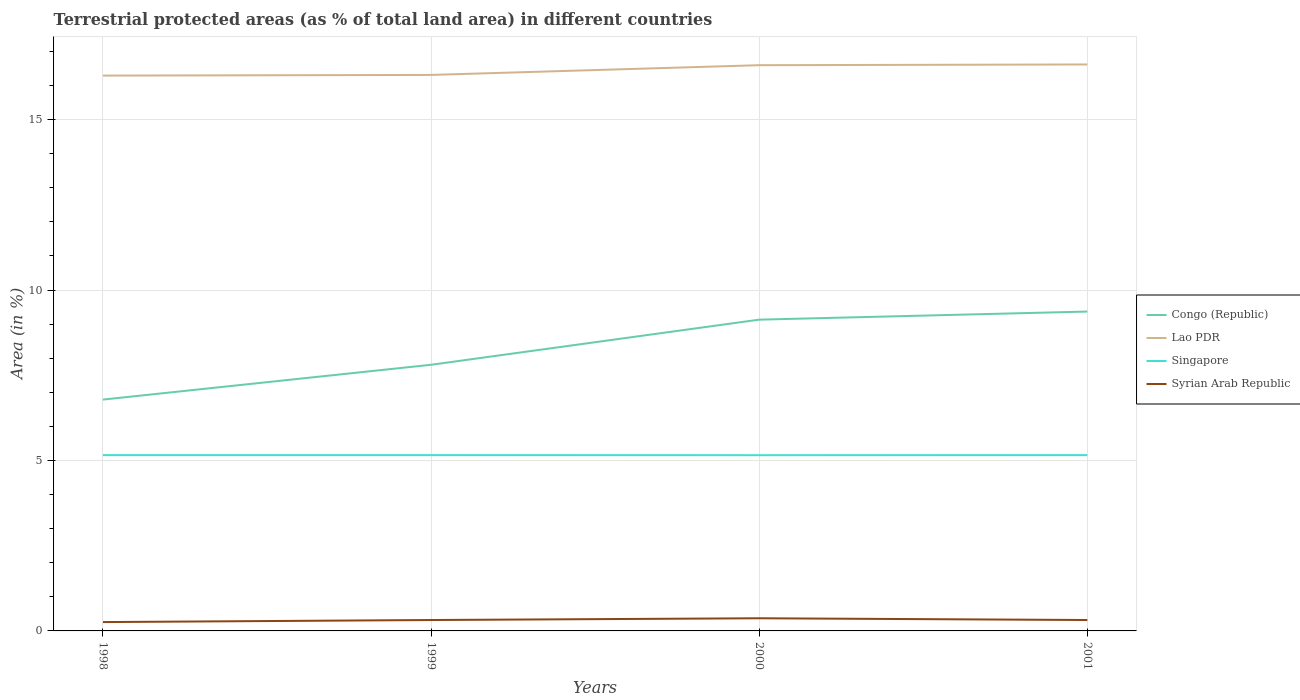Is the number of lines equal to the number of legend labels?
Provide a succinct answer. Yes. Across all years, what is the maximum percentage of terrestrial protected land in Congo (Republic)?
Give a very brief answer. 6.79. In which year was the percentage of terrestrial protected land in Singapore maximum?
Offer a very short reply. 2000. What is the total percentage of terrestrial protected land in Syrian Arab Republic in the graph?
Your answer should be compact. -0.06. What is the difference between the highest and the second highest percentage of terrestrial protected land in Congo (Republic)?
Offer a terse response. 2.58. How many lines are there?
Make the answer very short. 4. How many years are there in the graph?
Give a very brief answer. 4. Are the values on the major ticks of Y-axis written in scientific E-notation?
Keep it short and to the point. No. Does the graph contain any zero values?
Your response must be concise. No. How are the legend labels stacked?
Keep it short and to the point. Vertical. What is the title of the graph?
Keep it short and to the point. Terrestrial protected areas (as % of total land area) in different countries. Does "Australia" appear as one of the legend labels in the graph?
Offer a terse response. No. What is the label or title of the Y-axis?
Your answer should be compact. Area (in %). What is the Area (in %) of Congo (Republic) in 1998?
Your response must be concise. 6.79. What is the Area (in %) of Lao PDR in 1998?
Offer a terse response. 16.29. What is the Area (in %) of Singapore in 1998?
Keep it short and to the point. 5.16. What is the Area (in %) of Syrian Arab Republic in 1998?
Provide a short and direct response. 0.26. What is the Area (in %) in Congo (Republic) in 1999?
Your answer should be compact. 7.81. What is the Area (in %) in Lao PDR in 1999?
Keep it short and to the point. 16.31. What is the Area (in %) of Singapore in 1999?
Your response must be concise. 5.16. What is the Area (in %) of Syrian Arab Republic in 1999?
Make the answer very short. 0.32. What is the Area (in %) of Congo (Republic) in 2000?
Your response must be concise. 9.13. What is the Area (in %) of Lao PDR in 2000?
Offer a very short reply. 16.6. What is the Area (in %) in Singapore in 2000?
Make the answer very short. 5.16. What is the Area (in %) of Syrian Arab Republic in 2000?
Ensure brevity in your answer.  0.37. What is the Area (in %) in Congo (Republic) in 2001?
Your response must be concise. 9.37. What is the Area (in %) in Lao PDR in 2001?
Ensure brevity in your answer.  16.62. What is the Area (in %) of Singapore in 2001?
Ensure brevity in your answer.  5.16. What is the Area (in %) in Syrian Arab Republic in 2001?
Offer a terse response. 0.32. Across all years, what is the maximum Area (in %) in Congo (Republic)?
Offer a terse response. 9.37. Across all years, what is the maximum Area (in %) in Lao PDR?
Your response must be concise. 16.62. Across all years, what is the maximum Area (in %) of Singapore?
Provide a succinct answer. 5.16. Across all years, what is the maximum Area (in %) in Syrian Arab Republic?
Ensure brevity in your answer.  0.37. Across all years, what is the minimum Area (in %) in Congo (Republic)?
Your response must be concise. 6.79. Across all years, what is the minimum Area (in %) in Lao PDR?
Give a very brief answer. 16.29. Across all years, what is the minimum Area (in %) of Singapore?
Offer a terse response. 5.16. Across all years, what is the minimum Area (in %) of Syrian Arab Republic?
Provide a short and direct response. 0.26. What is the total Area (in %) in Congo (Republic) in the graph?
Ensure brevity in your answer.  33.1. What is the total Area (in %) in Lao PDR in the graph?
Provide a short and direct response. 65.82. What is the total Area (in %) in Singapore in the graph?
Ensure brevity in your answer.  20.63. What is the total Area (in %) in Syrian Arab Republic in the graph?
Make the answer very short. 1.27. What is the difference between the Area (in %) of Congo (Republic) in 1998 and that in 1999?
Make the answer very short. -1.02. What is the difference between the Area (in %) in Lao PDR in 1998 and that in 1999?
Your answer should be very brief. -0.02. What is the difference between the Area (in %) in Syrian Arab Republic in 1998 and that in 1999?
Your answer should be compact. -0.06. What is the difference between the Area (in %) in Congo (Republic) in 1998 and that in 2000?
Your response must be concise. -2.35. What is the difference between the Area (in %) in Lao PDR in 1998 and that in 2000?
Your answer should be very brief. -0.31. What is the difference between the Area (in %) in Singapore in 1998 and that in 2000?
Provide a short and direct response. 0. What is the difference between the Area (in %) of Syrian Arab Republic in 1998 and that in 2000?
Offer a very short reply. -0.11. What is the difference between the Area (in %) in Congo (Republic) in 1998 and that in 2001?
Your answer should be compact. -2.58. What is the difference between the Area (in %) of Lao PDR in 1998 and that in 2001?
Your response must be concise. -0.33. What is the difference between the Area (in %) in Syrian Arab Republic in 1998 and that in 2001?
Provide a succinct answer. -0.06. What is the difference between the Area (in %) in Congo (Republic) in 1999 and that in 2000?
Make the answer very short. -1.32. What is the difference between the Area (in %) in Lao PDR in 1999 and that in 2000?
Your answer should be very brief. -0.29. What is the difference between the Area (in %) of Singapore in 1999 and that in 2000?
Provide a short and direct response. 0. What is the difference between the Area (in %) of Syrian Arab Republic in 1999 and that in 2000?
Your answer should be very brief. -0.05. What is the difference between the Area (in %) in Congo (Republic) in 1999 and that in 2001?
Provide a short and direct response. -1.56. What is the difference between the Area (in %) in Lao PDR in 1999 and that in 2001?
Provide a short and direct response. -0.31. What is the difference between the Area (in %) in Syrian Arab Republic in 1999 and that in 2001?
Your answer should be compact. 0. What is the difference between the Area (in %) in Congo (Republic) in 2000 and that in 2001?
Give a very brief answer. -0.24. What is the difference between the Area (in %) of Lao PDR in 2000 and that in 2001?
Ensure brevity in your answer.  -0.02. What is the difference between the Area (in %) in Singapore in 2000 and that in 2001?
Make the answer very short. -0. What is the difference between the Area (in %) of Syrian Arab Republic in 2000 and that in 2001?
Offer a terse response. 0.05. What is the difference between the Area (in %) in Congo (Republic) in 1998 and the Area (in %) in Lao PDR in 1999?
Offer a very short reply. -9.52. What is the difference between the Area (in %) in Congo (Republic) in 1998 and the Area (in %) in Singapore in 1999?
Offer a terse response. 1.63. What is the difference between the Area (in %) in Congo (Republic) in 1998 and the Area (in %) in Syrian Arab Republic in 1999?
Provide a succinct answer. 6.47. What is the difference between the Area (in %) of Lao PDR in 1998 and the Area (in %) of Singapore in 1999?
Your response must be concise. 11.13. What is the difference between the Area (in %) of Lao PDR in 1998 and the Area (in %) of Syrian Arab Republic in 1999?
Offer a very short reply. 15.97. What is the difference between the Area (in %) of Singapore in 1998 and the Area (in %) of Syrian Arab Republic in 1999?
Offer a terse response. 4.84. What is the difference between the Area (in %) in Congo (Republic) in 1998 and the Area (in %) in Lao PDR in 2000?
Give a very brief answer. -9.81. What is the difference between the Area (in %) of Congo (Republic) in 1998 and the Area (in %) of Singapore in 2000?
Keep it short and to the point. 1.63. What is the difference between the Area (in %) in Congo (Republic) in 1998 and the Area (in %) in Syrian Arab Republic in 2000?
Offer a very short reply. 6.42. What is the difference between the Area (in %) of Lao PDR in 1998 and the Area (in %) of Singapore in 2000?
Offer a very short reply. 11.14. What is the difference between the Area (in %) of Lao PDR in 1998 and the Area (in %) of Syrian Arab Republic in 2000?
Provide a succinct answer. 15.92. What is the difference between the Area (in %) in Singapore in 1998 and the Area (in %) in Syrian Arab Republic in 2000?
Give a very brief answer. 4.79. What is the difference between the Area (in %) of Congo (Republic) in 1998 and the Area (in %) of Lao PDR in 2001?
Give a very brief answer. -9.83. What is the difference between the Area (in %) in Congo (Republic) in 1998 and the Area (in %) in Singapore in 2001?
Provide a succinct answer. 1.63. What is the difference between the Area (in %) of Congo (Republic) in 1998 and the Area (in %) of Syrian Arab Republic in 2001?
Provide a succinct answer. 6.47. What is the difference between the Area (in %) in Lao PDR in 1998 and the Area (in %) in Singapore in 2001?
Offer a very short reply. 11.13. What is the difference between the Area (in %) of Lao PDR in 1998 and the Area (in %) of Syrian Arab Republic in 2001?
Your response must be concise. 15.97. What is the difference between the Area (in %) in Singapore in 1998 and the Area (in %) in Syrian Arab Republic in 2001?
Your response must be concise. 4.84. What is the difference between the Area (in %) of Congo (Republic) in 1999 and the Area (in %) of Lao PDR in 2000?
Make the answer very short. -8.79. What is the difference between the Area (in %) of Congo (Republic) in 1999 and the Area (in %) of Singapore in 2000?
Provide a short and direct response. 2.65. What is the difference between the Area (in %) in Congo (Republic) in 1999 and the Area (in %) in Syrian Arab Republic in 2000?
Give a very brief answer. 7.44. What is the difference between the Area (in %) in Lao PDR in 1999 and the Area (in %) in Singapore in 2000?
Your response must be concise. 11.16. What is the difference between the Area (in %) of Lao PDR in 1999 and the Area (in %) of Syrian Arab Republic in 2000?
Give a very brief answer. 15.94. What is the difference between the Area (in %) of Singapore in 1999 and the Area (in %) of Syrian Arab Republic in 2000?
Make the answer very short. 4.79. What is the difference between the Area (in %) in Congo (Republic) in 1999 and the Area (in %) in Lao PDR in 2001?
Your answer should be very brief. -8.81. What is the difference between the Area (in %) in Congo (Republic) in 1999 and the Area (in %) in Singapore in 2001?
Your response must be concise. 2.65. What is the difference between the Area (in %) of Congo (Republic) in 1999 and the Area (in %) of Syrian Arab Republic in 2001?
Your answer should be compact. 7.49. What is the difference between the Area (in %) in Lao PDR in 1999 and the Area (in %) in Singapore in 2001?
Make the answer very short. 11.15. What is the difference between the Area (in %) of Lao PDR in 1999 and the Area (in %) of Syrian Arab Republic in 2001?
Offer a terse response. 15.99. What is the difference between the Area (in %) of Singapore in 1999 and the Area (in %) of Syrian Arab Republic in 2001?
Keep it short and to the point. 4.84. What is the difference between the Area (in %) of Congo (Republic) in 2000 and the Area (in %) of Lao PDR in 2001?
Give a very brief answer. -7.49. What is the difference between the Area (in %) in Congo (Republic) in 2000 and the Area (in %) in Singapore in 2001?
Make the answer very short. 3.97. What is the difference between the Area (in %) in Congo (Republic) in 2000 and the Area (in %) in Syrian Arab Republic in 2001?
Your answer should be very brief. 8.81. What is the difference between the Area (in %) in Lao PDR in 2000 and the Area (in %) in Singapore in 2001?
Make the answer very short. 11.44. What is the difference between the Area (in %) in Lao PDR in 2000 and the Area (in %) in Syrian Arab Republic in 2001?
Your response must be concise. 16.28. What is the difference between the Area (in %) of Singapore in 2000 and the Area (in %) of Syrian Arab Republic in 2001?
Make the answer very short. 4.84. What is the average Area (in %) of Congo (Republic) per year?
Provide a short and direct response. 8.27. What is the average Area (in %) in Lao PDR per year?
Your answer should be very brief. 16.45. What is the average Area (in %) of Singapore per year?
Ensure brevity in your answer.  5.16. What is the average Area (in %) of Syrian Arab Republic per year?
Ensure brevity in your answer.  0.32. In the year 1998, what is the difference between the Area (in %) in Congo (Republic) and Area (in %) in Lao PDR?
Ensure brevity in your answer.  -9.5. In the year 1998, what is the difference between the Area (in %) of Congo (Republic) and Area (in %) of Singapore?
Give a very brief answer. 1.63. In the year 1998, what is the difference between the Area (in %) of Congo (Republic) and Area (in %) of Syrian Arab Republic?
Your response must be concise. 6.53. In the year 1998, what is the difference between the Area (in %) of Lao PDR and Area (in %) of Singapore?
Provide a succinct answer. 11.13. In the year 1998, what is the difference between the Area (in %) in Lao PDR and Area (in %) in Syrian Arab Republic?
Give a very brief answer. 16.03. In the year 1998, what is the difference between the Area (in %) in Singapore and Area (in %) in Syrian Arab Republic?
Offer a very short reply. 4.9. In the year 1999, what is the difference between the Area (in %) of Congo (Republic) and Area (in %) of Lao PDR?
Provide a succinct answer. -8.5. In the year 1999, what is the difference between the Area (in %) of Congo (Republic) and Area (in %) of Singapore?
Offer a terse response. 2.65. In the year 1999, what is the difference between the Area (in %) of Congo (Republic) and Area (in %) of Syrian Arab Republic?
Your response must be concise. 7.49. In the year 1999, what is the difference between the Area (in %) of Lao PDR and Area (in %) of Singapore?
Keep it short and to the point. 11.15. In the year 1999, what is the difference between the Area (in %) in Lao PDR and Area (in %) in Syrian Arab Republic?
Give a very brief answer. 15.99. In the year 1999, what is the difference between the Area (in %) in Singapore and Area (in %) in Syrian Arab Republic?
Keep it short and to the point. 4.84. In the year 2000, what is the difference between the Area (in %) in Congo (Republic) and Area (in %) in Lao PDR?
Offer a very short reply. -7.47. In the year 2000, what is the difference between the Area (in %) of Congo (Republic) and Area (in %) of Singapore?
Your answer should be very brief. 3.98. In the year 2000, what is the difference between the Area (in %) of Congo (Republic) and Area (in %) of Syrian Arab Republic?
Ensure brevity in your answer.  8.76. In the year 2000, what is the difference between the Area (in %) of Lao PDR and Area (in %) of Singapore?
Keep it short and to the point. 11.44. In the year 2000, what is the difference between the Area (in %) of Lao PDR and Area (in %) of Syrian Arab Republic?
Your response must be concise. 16.23. In the year 2000, what is the difference between the Area (in %) in Singapore and Area (in %) in Syrian Arab Republic?
Make the answer very short. 4.78. In the year 2001, what is the difference between the Area (in %) of Congo (Republic) and Area (in %) of Lao PDR?
Provide a short and direct response. -7.25. In the year 2001, what is the difference between the Area (in %) of Congo (Republic) and Area (in %) of Singapore?
Your answer should be very brief. 4.21. In the year 2001, what is the difference between the Area (in %) in Congo (Republic) and Area (in %) in Syrian Arab Republic?
Your response must be concise. 9.05. In the year 2001, what is the difference between the Area (in %) in Lao PDR and Area (in %) in Singapore?
Give a very brief answer. 11.46. In the year 2001, what is the difference between the Area (in %) in Lao PDR and Area (in %) in Syrian Arab Republic?
Ensure brevity in your answer.  16.3. In the year 2001, what is the difference between the Area (in %) in Singapore and Area (in %) in Syrian Arab Republic?
Your answer should be compact. 4.84. What is the ratio of the Area (in %) of Congo (Republic) in 1998 to that in 1999?
Offer a terse response. 0.87. What is the ratio of the Area (in %) of Syrian Arab Republic in 1998 to that in 1999?
Offer a terse response. 0.81. What is the ratio of the Area (in %) in Congo (Republic) in 1998 to that in 2000?
Offer a very short reply. 0.74. What is the ratio of the Area (in %) in Lao PDR in 1998 to that in 2000?
Give a very brief answer. 0.98. What is the ratio of the Area (in %) of Syrian Arab Republic in 1998 to that in 2000?
Offer a terse response. 0.7. What is the ratio of the Area (in %) in Congo (Republic) in 1998 to that in 2001?
Your answer should be compact. 0.72. What is the ratio of the Area (in %) in Lao PDR in 1998 to that in 2001?
Your response must be concise. 0.98. What is the ratio of the Area (in %) in Syrian Arab Republic in 1998 to that in 2001?
Keep it short and to the point. 0.81. What is the ratio of the Area (in %) in Congo (Republic) in 1999 to that in 2000?
Offer a very short reply. 0.86. What is the ratio of the Area (in %) in Lao PDR in 1999 to that in 2000?
Offer a terse response. 0.98. What is the ratio of the Area (in %) of Singapore in 1999 to that in 2000?
Ensure brevity in your answer.  1. What is the ratio of the Area (in %) in Syrian Arab Republic in 1999 to that in 2000?
Make the answer very short. 0.86. What is the ratio of the Area (in %) of Congo (Republic) in 1999 to that in 2001?
Make the answer very short. 0.83. What is the ratio of the Area (in %) in Lao PDR in 1999 to that in 2001?
Your response must be concise. 0.98. What is the ratio of the Area (in %) of Syrian Arab Republic in 1999 to that in 2001?
Provide a succinct answer. 1. What is the ratio of the Area (in %) in Congo (Republic) in 2000 to that in 2001?
Your answer should be compact. 0.97. What is the ratio of the Area (in %) of Syrian Arab Republic in 2000 to that in 2001?
Ensure brevity in your answer.  1.16. What is the difference between the highest and the second highest Area (in %) in Congo (Republic)?
Make the answer very short. 0.24. What is the difference between the highest and the second highest Area (in %) in Lao PDR?
Your response must be concise. 0.02. What is the difference between the highest and the second highest Area (in %) of Syrian Arab Republic?
Your answer should be compact. 0.05. What is the difference between the highest and the lowest Area (in %) in Congo (Republic)?
Provide a short and direct response. 2.58. What is the difference between the highest and the lowest Area (in %) in Lao PDR?
Give a very brief answer. 0.33. What is the difference between the highest and the lowest Area (in %) in Singapore?
Provide a succinct answer. 0. What is the difference between the highest and the lowest Area (in %) of Syrian Arab Republic?
Offer a very short reply. 0.11. 